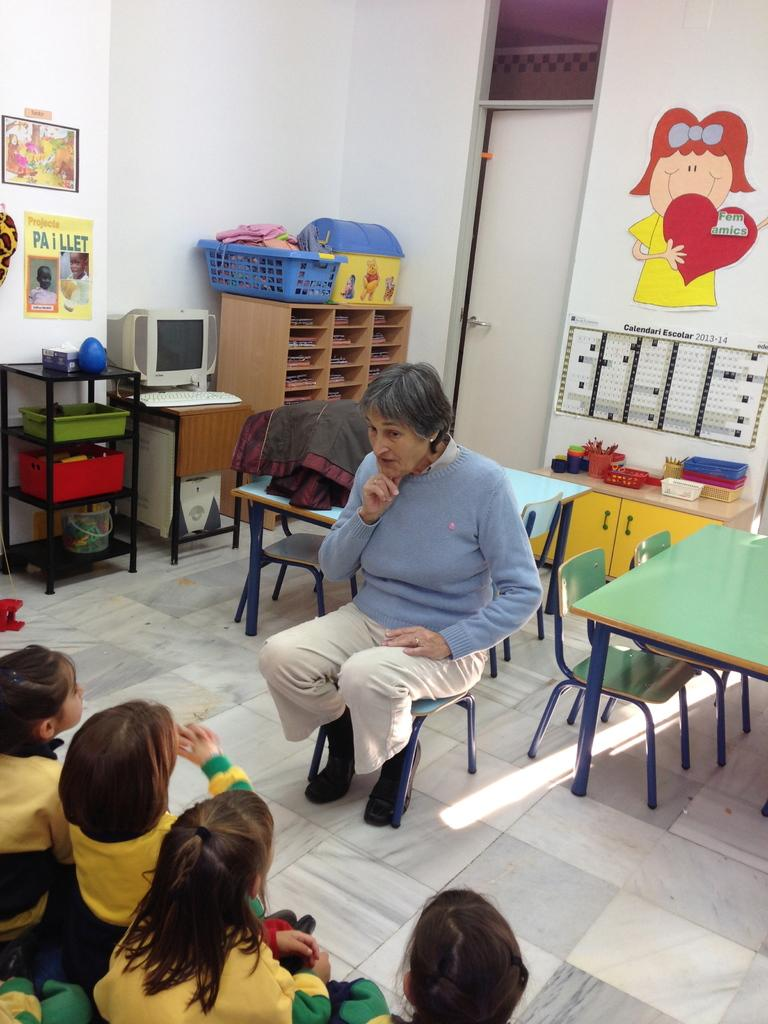<image>
Render a clear and concise summary of the photo. A yellow poster is hung on a wall titled, "Paillet." 